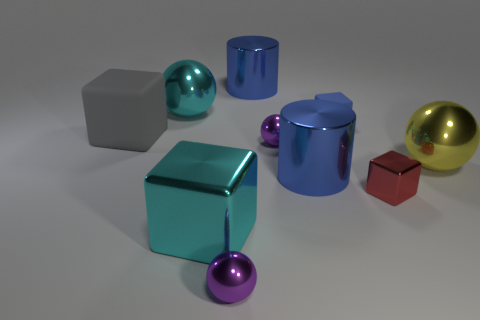What number of purple things are in front of the big cube in front of the large yellow ball?
Provide a succinct answer. 1. Does the red block in front of the large rubber thing have the same material as the tiny purple object that is behind the yellow metallic thing?
Offer a terse response. Yes. There is a large ball that is the same color as the large metallic cube; what material is it?
Provide a succinct answer. Metal. What number of small blue rubber things are the same shape as the big gray matte thing?
Offer a very short reply. 1. Does the large cyan sphere have the same material as the big blue cylinder behind the big yellow metallic thing?
Give a very brief answer. Yes. There is a block that is the same size as the blue matte thing; what is it made of?
Offer a terse response. Metal. Are there any yellow spheres that have the same size as the gray cube?
Provide a short and direct response. Yes. There is a cyan thing that is the same size as the cyan sphere; what shape is it?
Offer a very short reply. Cube. What number of other things are the same color as the tiny matte object?
Provide a succinct answer. 2. The metallic thing that is on the right side of the blue rubber thing and left of the yellow thing has what shape?
Offer a terse response. Cube. 